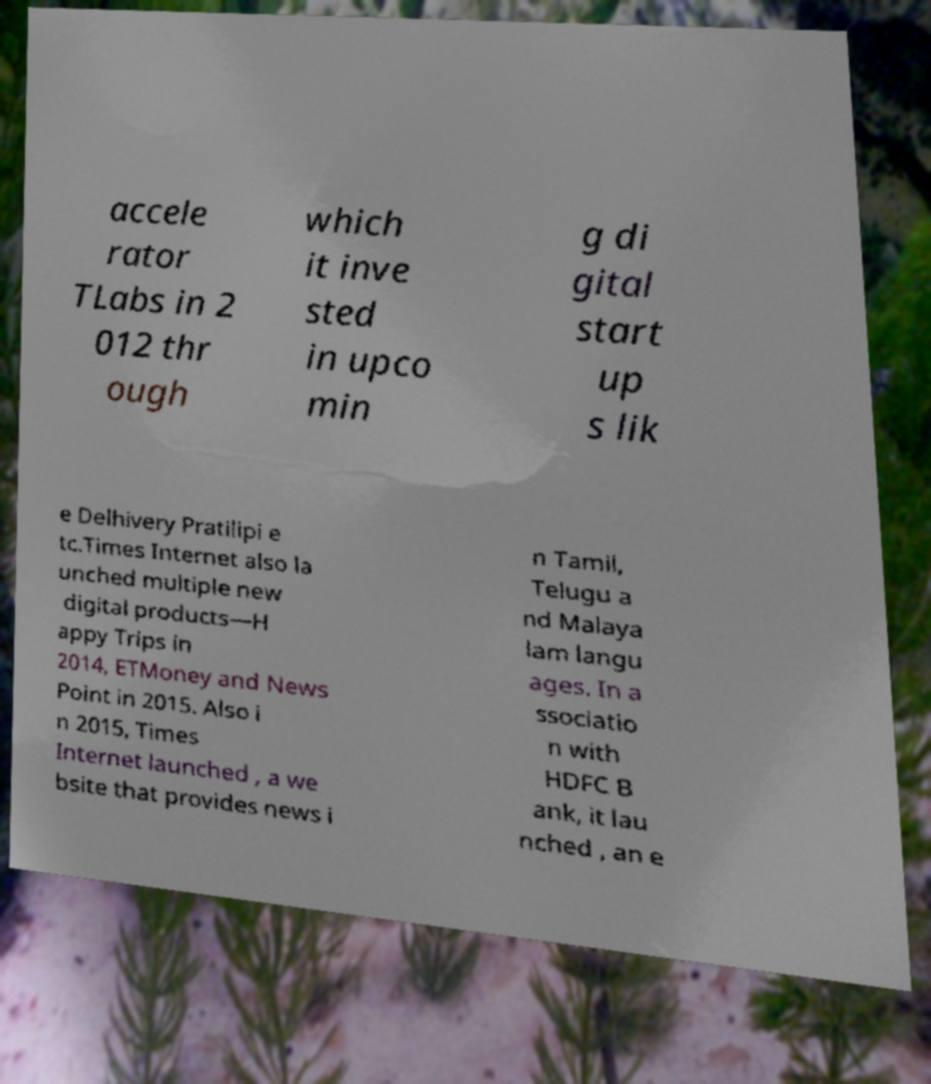Please read and relay the text visible in this image. What does it say? accele rator TLabs in 2 012 thr ough which it inve sted in upco min g di gital start up s lik e Delhivery Pratilipi e tc.Times Internet also la unched multiple new digital products—H appy Trips in 2014, ETMoney and News Point in 2015. Also i n 2015, Times Internet launched , a we bsite that provides news i n Tamil, Telugu a nd Malaya lam langu ages. In a ssociatio n with HDFC B ank, it lau nched , an e 